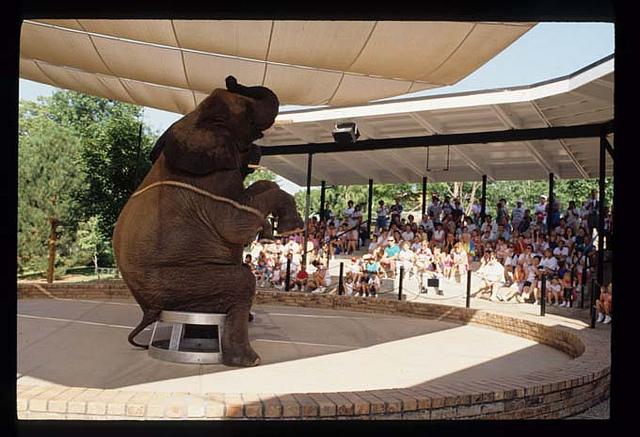Is the elephant sitting on a chair?
Short answer required. Yes. Are there many people in the audience?
Be succinct. Yes. Could this be a pachyderm?
Quick response, please. Yes. 